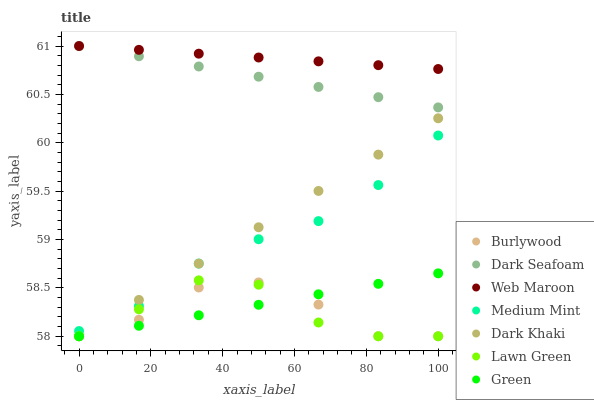Does Lawn Green have the minimum area under the curve?
Answer yes or no. Yes. Does Web Maroon have the maximum area under the curve?
Answer yes or no. Yes. Does Burlywood have the minimum area under the curve?
Answer yes or no. No. Does Burlywood have the maximum area under the curve?
Answer yes or no. No. Is Web Maroon the smoothest?
Answer yes or no. Yes. Is Burlywood the roughest?
Answer yes or no. Yes. Is Lawn Green the smoothest?
Answer yes or no. No. Is Lawn Green the roughest?
Answer yes or no. No. Does Lawn Green have the lowest value?
Answer yes or no. Yes. Does Web Maroon have the lowest value?
Answer yes or no. No. Does Dark Seafoam have the highest value?
Answer yes or no. Yes. Does Lawn Green have the highest value?
Answer yes or no. No. Is Green less than Web Maroon?
Answer yes or no. Yes. Is Web Maroon greater than Lawn Green?
Answer yes or no. Yes. Does Green intersect Dark Khaki?
Answer yes or no. Yes. Is Green less than Dark Khaki?
Answer yes or no. No. Is Green greater than Dark Khaki?
Answer yes or no. No. Does Green intersect Web Maroon?
Answer yes or no. No. 